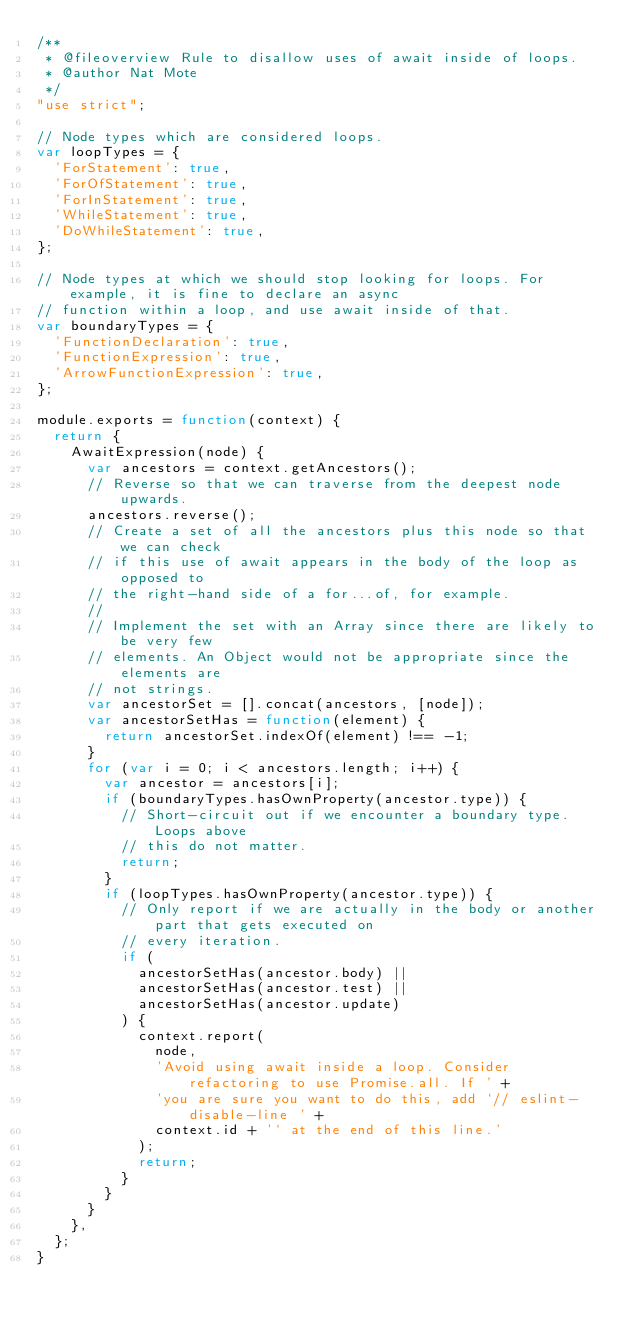Convert code to text. <code><loc_0><loc_0><loc_500><loc_500><_JavaScript_>/**
 * @fileoverview Rule to disallow uses of await inside of loops.
 * @author Nat Mote
 */
"use strict";

// Node types which are considered loops.
var loopTypes = {
  'ForStatement': true,
  'ForOfStatement': true,
  'ForInStatement': true,
  'WhileStatement': true,
  'DoWhileStatement': true,
};

// Node types at which we should stop looking for loops. For example, it is fine to declare an async
// function within a loop, and use await inside of that.
var boundaryTypes = {
  'FunctionDeclaration': true,
  'FunctionExpression': true,
  'ArrowFunctionExpression': true,
};

module.exports = function(context) {
  return {
    AwaitExpression(node) {
      var ancestors = context.getAncestors();
      // Reverse so that we can traverse from the deepest node upwards.
      ancestors.reverse();
      // Create a set of all the ancestors plus this node so that we can check
      // if this use of await appears in the body of the loop as opposed to
      // the right-hand side of a for...of, for example.
      //
      // Implement the set with an Array since there are likely to be very few
      // elements. An Object would not be appropriate since the elements are
      // not strings.
      var ancestorSet = [].concat(ancestors, [node]);
      var ancestorSetHas = function(element) {
        return ancestorSet.indexOf(element) !== -1;
      }
      for (var i = 0; i < ancestors.length; i++) {
        var ancestor = ancestors[i];
        if (boundaryTypes.hasOwnProperty(ancestor.type)) {
          // Short-circuit out if we encounter a boundary type. Loops above
          // this do not matter.
          return;
        }
        if (loopTypes.hasOwnProperty(ancestor.type)) {
          // Only report if we are actually in the body or another part that gets executed on
          // every iteration.
          if (
            ancestorSetHas(ancestor.body) ||
            ancestorSetHas(ancestor.test) ||
            ancestorSetHas(ancestor.update)
          ) {
            context.report(
              node,
              'Avoid using await inside a loop. Consider refactoring to use Promise.all. If ' +
              'you are sure you want to do this, add `// eslint-disable-line ' +
              context.id + '` at the end of this line.'
            );
            return;
          }
        }
      }
    },
  };
}
</code> 